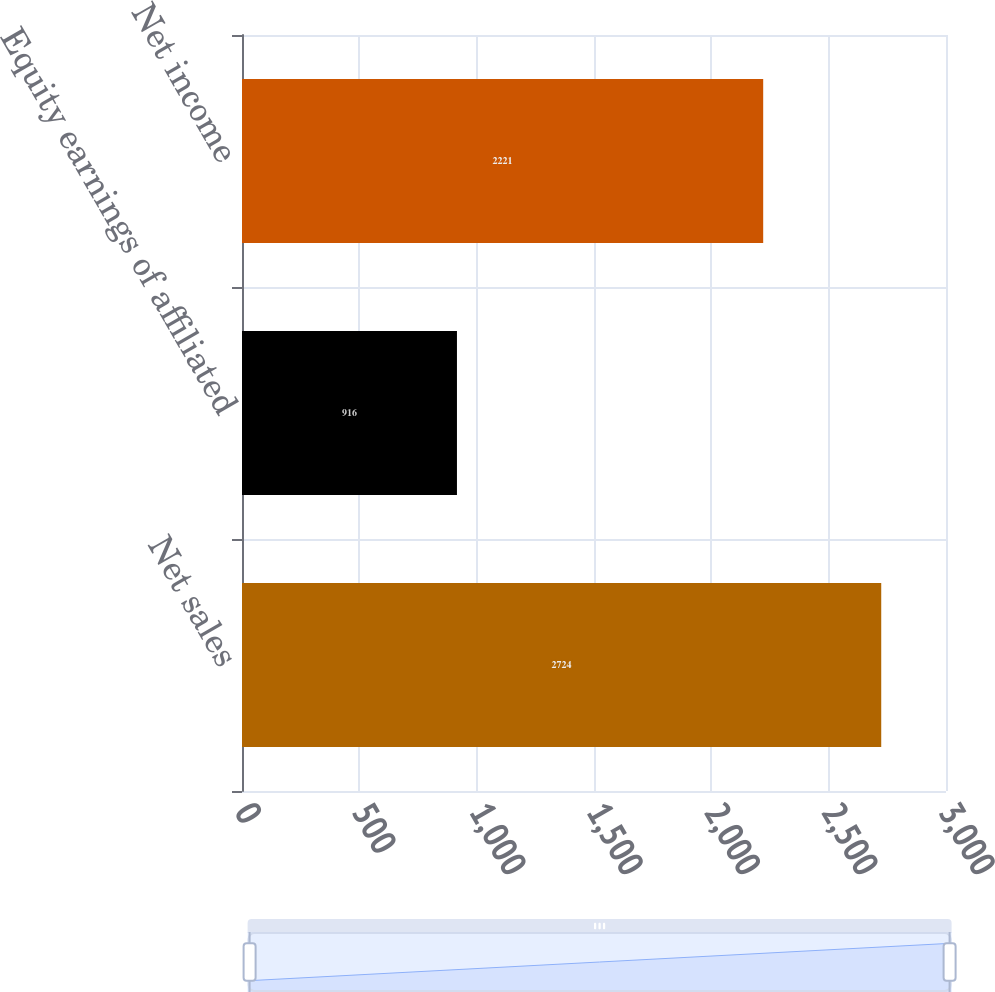Convert chart. <chart><loc_0><loc_0><loc_500><loc_500><bar_chart><fcel>Net sales<fcel>Equity earnings of affiliated<fcel>Net income<nl><fcel>2724<fcel>916<fcel>2221<nl></chart> 